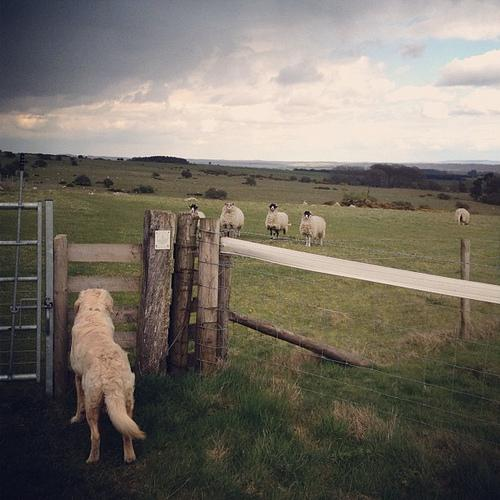How many sheep are in the image and what are they doing? There are four sheep in the image, standing and grazing in a field with green and brown grass. Briefly describe the sky's appearance in the image. The sky is blue and full of white clouds, creating a somewhat cloudy but pleasant atmosphere. Count and describe the number of trees in the background. There is an area of trees in the middle of the field, consisting of multiple trees but the exact number is not provided. What is the setting of the image and the color of the grass? The setting is a large field of grass with a mix of green and brown colors, with a group of trees in the background. What kind of gate is near the dog and what additional feature is on it? An iron gate is next to the dog, with a lock attached to it. What type of fence is surrounding the sheep and what is its condition? A wood and wire fence surrounds the sheep, with a grey metal gate and some wooden poles in good condition. How many sheep in the image have black faces? Two white sheep in the image have black faces. Identify the predominant animal in the image and describe its appearance. A furry white sheep dog with a long tail is standing outside, looking through a wooden fence. What is a unique feature about the dog's tail in the image? The dog's tail is wagging, indicating happiness or excitement. Explain the relationship between the dog and the sheep in the image. The white dog with a long tail is watching the sheep from behind a wooden fence, possibly guarding or herding them. List three distinct features of this image. a grey metal gate, a group of sheep, and a wooden pole on the fence Is the sheep standing on top of a tree in the middle of the image? Sheep are mentioned in the field or grass. They are not known for climbing trees or being among trees, making this instruction misleading. Where is the lock located? The lock is on the gate. What is the most prominent feature of the landscape in the image? a large field of grass Which animals are present in this image and where are they located? There are sheep in a field and a dog standing next to a gate. Is there an orange brick wall behind the metal gate? There is no mention of any wall, especially not an orange or brick one, in the given information. Thus, this instruction is misleading. Is the dog standing near the cloud on the left side of the image? The dog in the image is on the ground level and the cloud is in the sky, making it impossible for both to be at the same location in the image. Which animal appears to have more fur: the dog or the sheep? The dog appears to have more fur. Can you spot a flock of birds flying above the wooden fence? There is no mention of birds or any flying elements in the provided image information. Thus, this instruction would be incorrect. What type of fence surrounds the sheep? a wood and wire fence The grass in this image has two colors. What are they? The grass is green and brown. Can you see a young girl holding a sheep on the right side of the image? There is no mention of a young girl in the given information, only sheep, a dog, and background elements like a fence, trees, and clouds. Is there a purple car parked nearby the sheep in the field? There is no mention of a car or any color other than white, black, green, and blue in the image; hence, there is no purple car in the image. What is guarding the sheep in the field? A white dog and a wooden fence. What is the dominant feature in the top part of the image? a cloudy sky What is the color of the sheep's faces? The sheep have black faces. What objects are visible in the lower left corner of the image? Part of the grass and the dog's tail are visible in the lower left corner. Count the number of sheep in the field. There are four sheep in the field. Does the dog have a short or long tail? The dog has a long tail. What are the three wood post in the ground part of? They are part of the wood and wire fence. What color is the sky in this image? The sky is blue with white clouds. What is the most distinct part of the dog? Its long tail Describe the relationship between the dog and the sheep. The dog is watching the sheep behind a fence. Is the dog looking at the sheep? B: No 